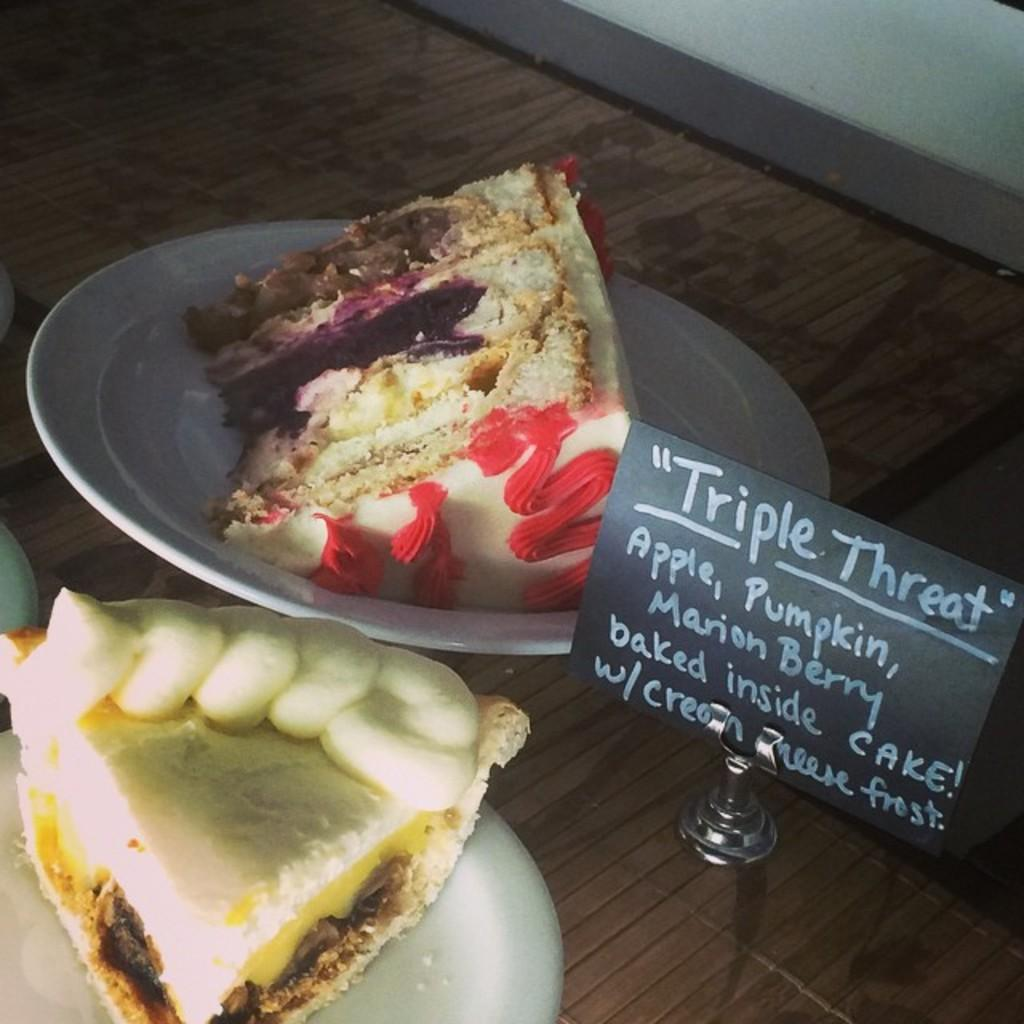What objects can be seen in the image that are used for serving food? There are plates in the image that are used for serving food. What type of food is visible on the plates? There are slices of food on the plates. What can be read or seen on the board in the image? There is a board with text on it in the image. What type of surface is visible in the image? The wooden surface is visible in the image. What architectural feature can be seen in the top right corner of the image? There is a wall in the top right corner of the image. How many goldfish are swimming in the wooden surface in the image? There are no goldfish present in the image; the wooden surface is a flat surface for serving food. 